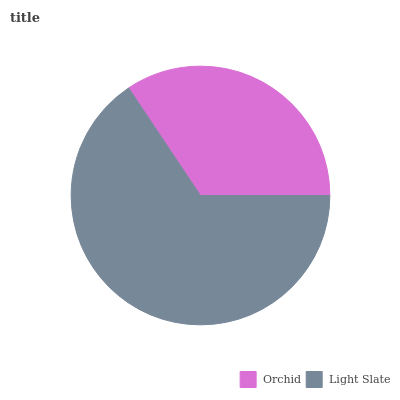Is Orchid the minimum?
Answer yes or no. Yes. Is Light Slate the maximum?
Answer yes or no. Yes. Is Light Slate the minimum?
Answer yes or no. No. Is Light Slate greater than Orchid?
Answer yes or no. Yes. Is Orchid less than Light Slate?
Answer yes or no. Yes. Is Orchid greater than Light Slate?
Answer yes or no. No. Is Light Slate less than Orchid?
Answer yes or no. No. Is Light Slate the high median?
Answer yes or no. Yes. Is Orchid the low median?
Answer yes or no. Yes. Is Orchid the high median?
Answer yes or no. No. Is Light Slate the low median?
Answer yes or no. No. 